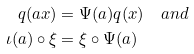<formula> <loc_0><loc_0><loc_500><loc_500>q ( a x ) & = \Psi ( a ) q ( x ) \quad a n d \\ \iota ( a ) \circ \xi & = \xi \circ \Psi ( a )</formula> 